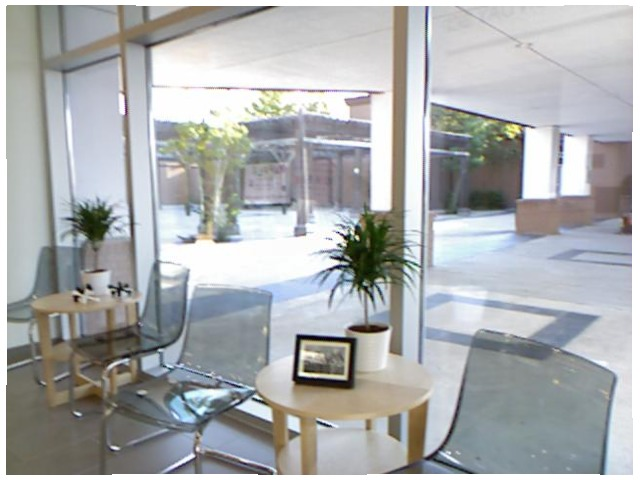<image>
Can you confirm if the table is under the plant? Yes. The table is positioned underneath the plant, with the plant above it in the vertical space. Where is the plant in relation to the table? Is it behind the table? No. The plant is not behind the table. From this viewpoint, the plant appears to be positioned elsewhere in the scene. 